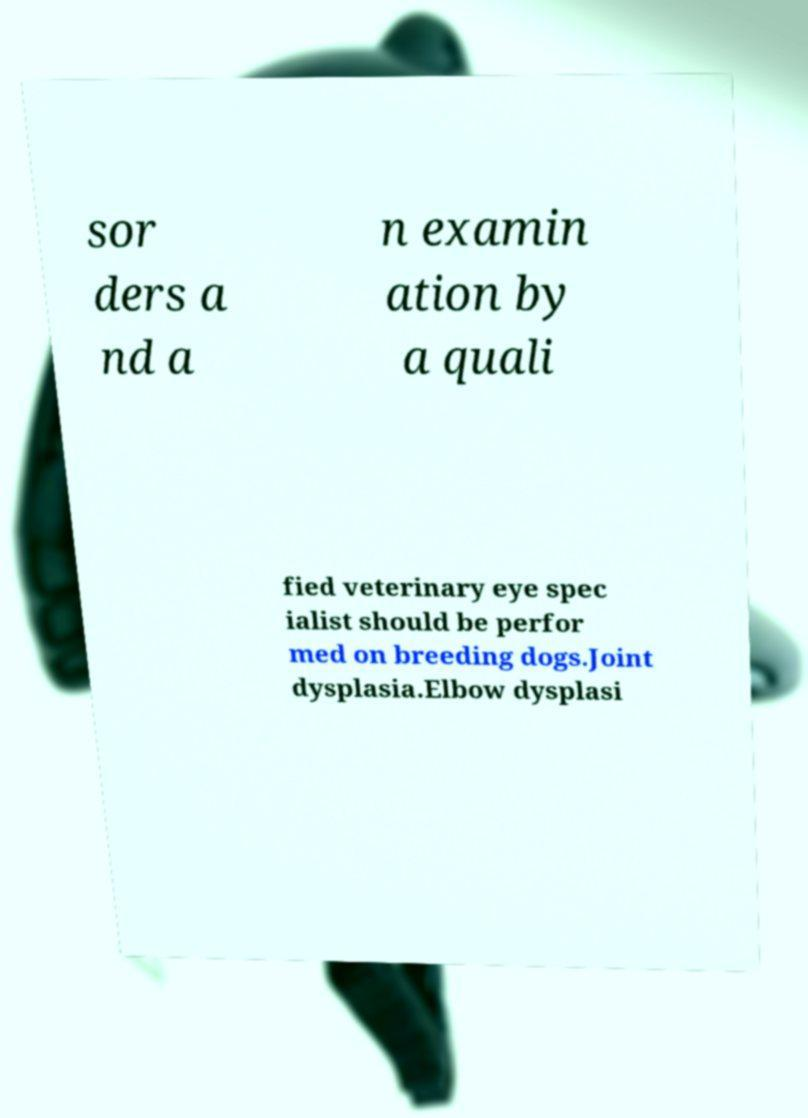For documentation purposes, I need the text within this image transcribed. Could you provide that? sor ders a nd a n examin ation by a quali fied veterinary eye spec ialist should be perfor med on breeding dogs.Joint dysplasia.Elbow dysplasi 